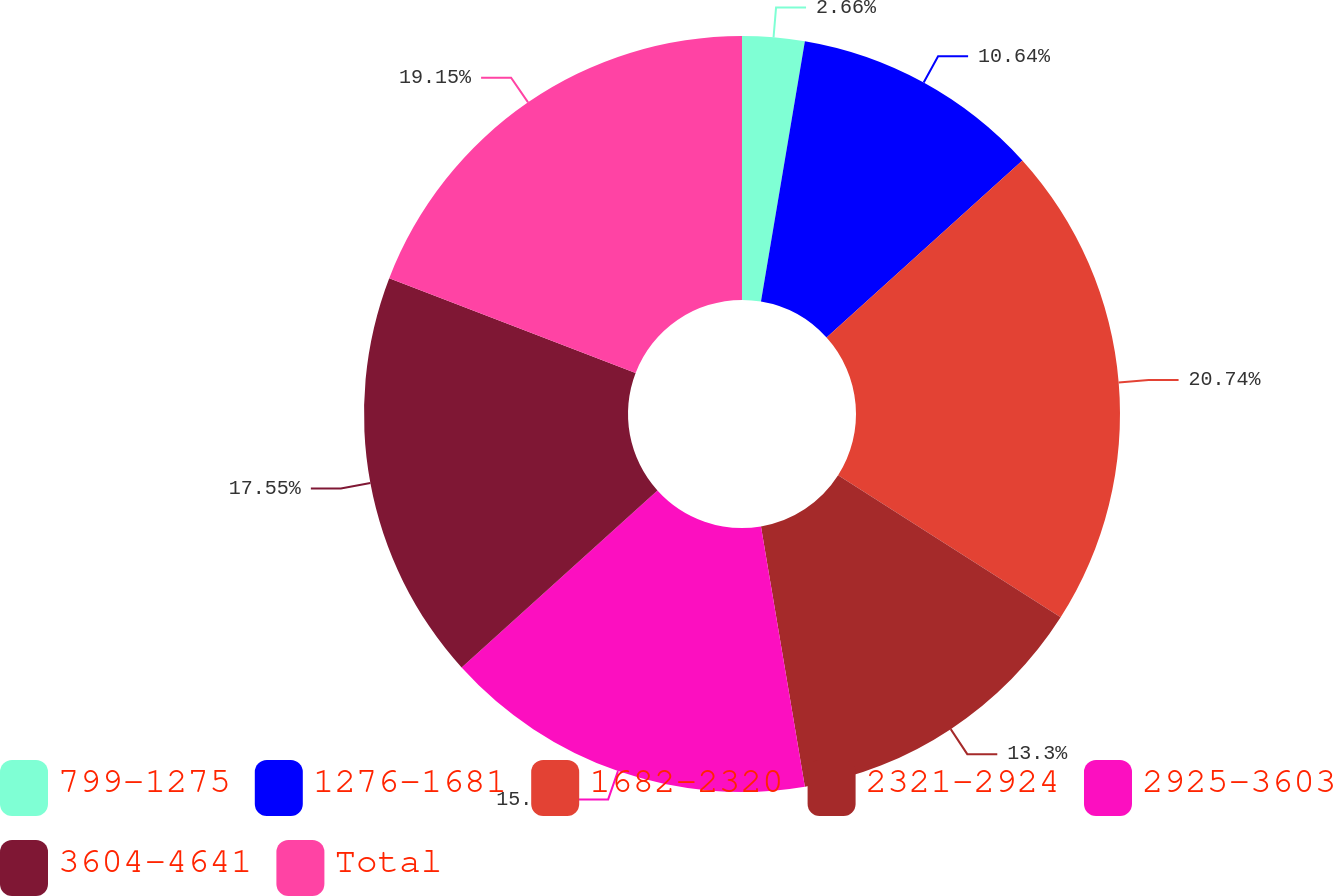<chart> <loc_0><loc_0><loc_500><loc_500><pie_chart><fcel>799-1275<fcel>1276-1681<fcel>1682-2320<fcel>2321-2924<fcel>2925-3603<fcel>3604-4641<fcel>Total<nl><fcel>2.66%<fcel>10.64%<fcel>20.74%<fcel>13.3%<fcel>15.96%<fcel>17.55%<fcel>19.15%<nl></chart> 